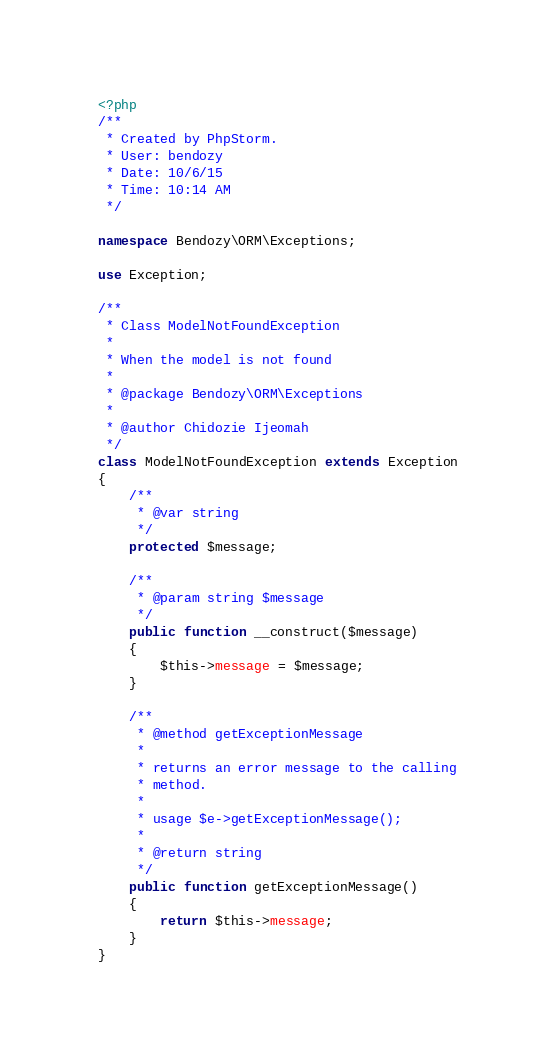Convert code to text. <code><loc_0><loc_0><loc_500><loc_500><_PHP_><?php
/**
 * Created by PhpStorm.
 * User: bendozy
 * Date: 10/6/15
 * Time: 10:14 AM
 */

namespace Bendozy\ORM\Exceptions;

use Exception;

/**
 * Class ModelNotFoundException
 *
 * When the model is not found
 *
 * @package Bendozy\ORM\Exceptions
 *
 * @author Chidozie Ijeomah
 */
class ModelNotFoundException extends Exception
{
	/**
	 * @var string
	 */
	protected $message;

	/**
	 * @param string $message
	 */
	public function __construct($message)
	{
		$this->message = $message;
	}

	/**
	 * @method getExceptionMessage
	 *
	 * returns an error message to the calling
	 * method.
	 *
	 * usage $e->getExceptionMessage();
	 *
	 * @return string
	 */
	public function getExceptionMessage()
	{
		return $this->message;
	}
} </code> 